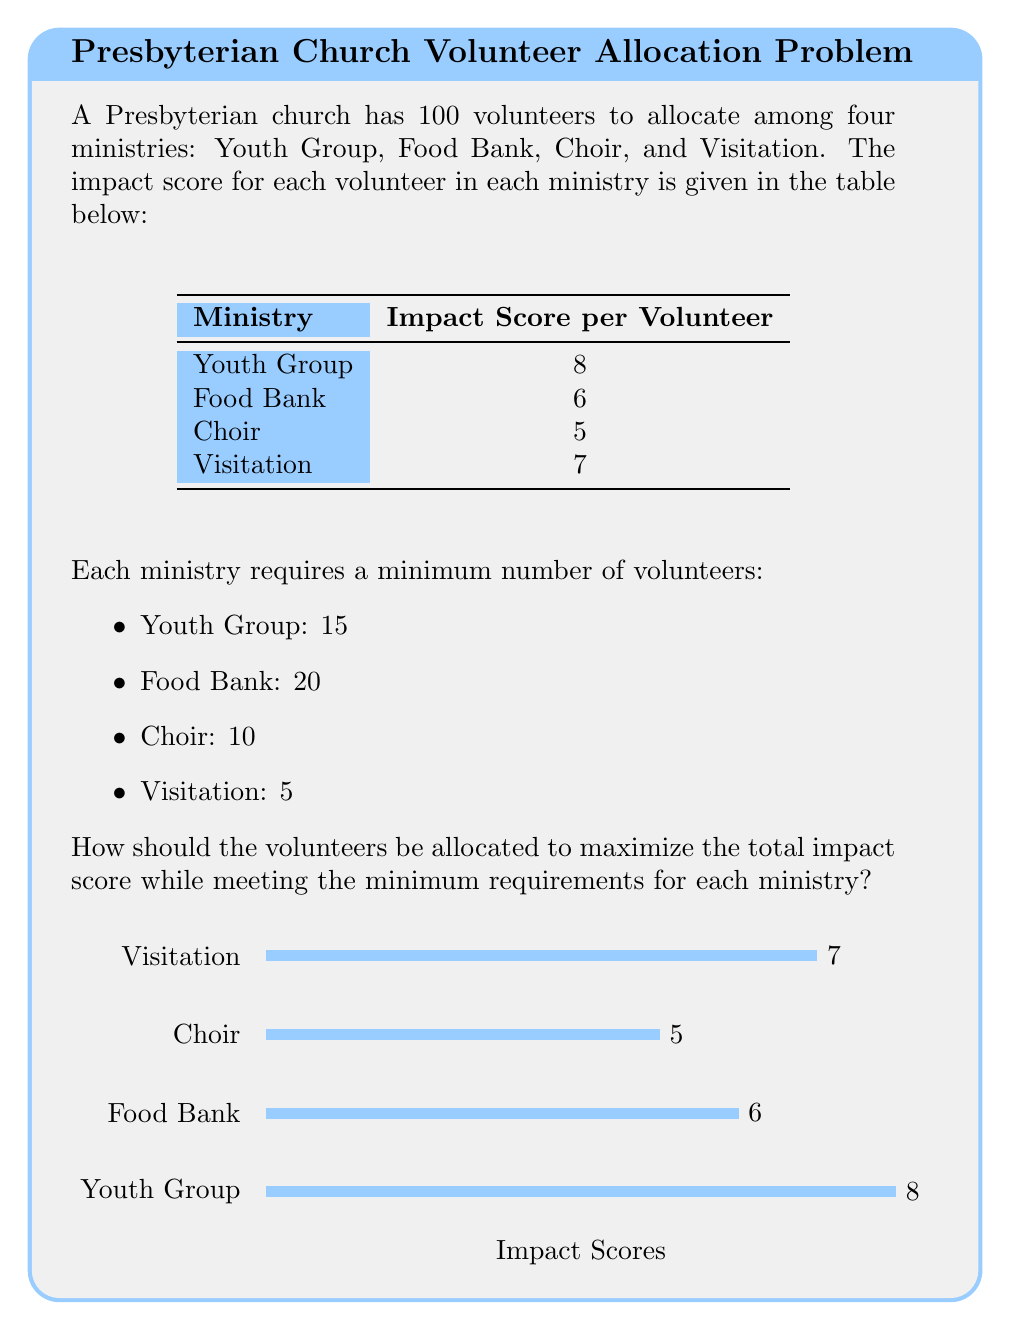Can you solve this math problem? To solve this optimization problem, we'll use the simplex method for linear programming. Let's define our variables:

$x_1$ = number of volunteers for Youth Group
$x_2$ = number of volunteers for Food Bank
$x_3$ = number of volunteers for Choir
$x_4$ = number of volunteers for Visitation

Our objective function to maximize is:

$$ \text{maximize } Z = 8x_1 + 6x_2 + 5x_3 + 7x_4 $$

Subject to the constraints:

1) Minimum requirements:
   $x_1 \geq 15$
   $x_2 \geq 20$
   $x_3 \geq 10$
   $x_4 \geq 5$

2) Total volunteers:
   $x_1 + x_2 + x_3 + x_4 = 100$

3) Non-negativity:
   $x_1, x_2, x_3, x_4 \geq 0$

To solve this, we'll use the following steps:

1) Allocate the minimum required volunteers:
   Youth Group: 15
   Food Bank: 20
   Choir: 10
   Visitation: 5
   Total: 50

2) We have 50 volunteers left to allocate.

3) To maximize impact, we should allocate the remaining volunteers to the ministry with the highest impact score, which is the Youth Group (8 points per volunteer).

4) Allocate all 50 remaining volunteers to the Youth Group.

5) Final allocation:
   Youth Group: 15 + 50 = 65
   Food Bank: 20
   Choir: 10
   Visitation: 5

6) Calculate total impact:
   $Z = 8(65) + 6(20) + 5(10) + 7(5) = 520 + 120 + 50 + 35 = 725$

This allocation maximizes the total impact while meeting all constraints.
Answer: Youth Group: 65, Food Bank: 20, Choir: 10, Visitation: 5; Total impact: 725 